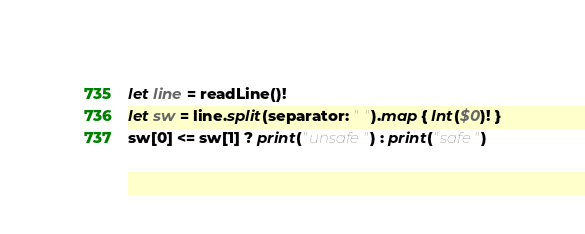Convert code to text. <code><loc_0><loc_0><loc_500><loc_500><_Swift_>let line = readLine()!
let sw = line.split(separator: " ").map { Int($0)! }
sw[0] <= sw[1] ? print("unsafe") : print("safe")</code> 